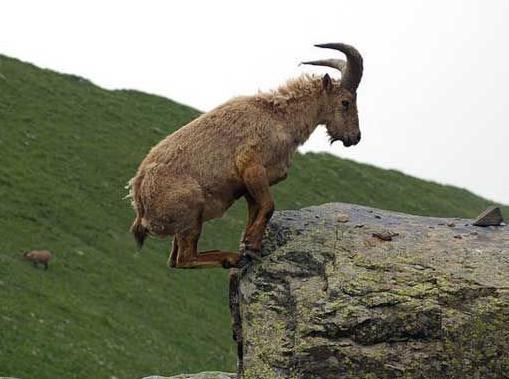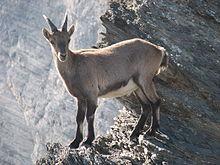The first image is the image on the left, the second image is the image on the right. Given the left and right images, does the statement "Each individual image has exactly one animal in it." hold true? Answer yes or no. Yes. 